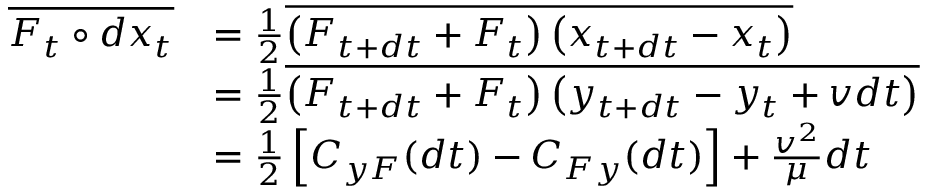Convert formula to latex. <formula><loc_0><loc_0><loc_500><loc_500>\begin{array} { r l } { \overline { { F _ { t } \circ d { x } _ { t } } } } & { = \frac { 1 } { 2 } \overline { { \left ( F _ { t + d t } + F _ { t } \right ) \left ( x _ { t + d t } - x _ { t } \right ) } } } \\ & { = \frac { 1 } { 2 } \overline { { \left ( F _ { t + d t } + F _ { t } \right ) \left ( y _ { t + d t } - y _ { t } + v d t \right ) } } } \\ & { = \frac { 1 } { 2 } \left [ C _ { y F } ( d t ) - C _ { F y } ( d t ) \right ] + \frac { v ^ { 2 } } { \mu } d t } \end{array}</formula> 